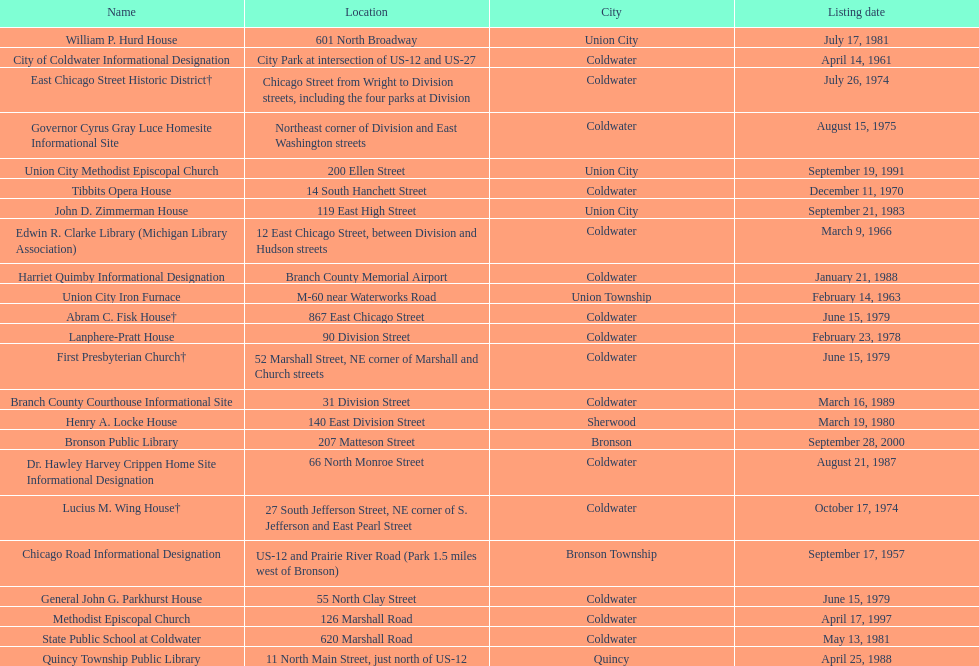Which site was listed earlier, the state public school or the edwin r. clarke library? Edwin R. Clarke Library. 